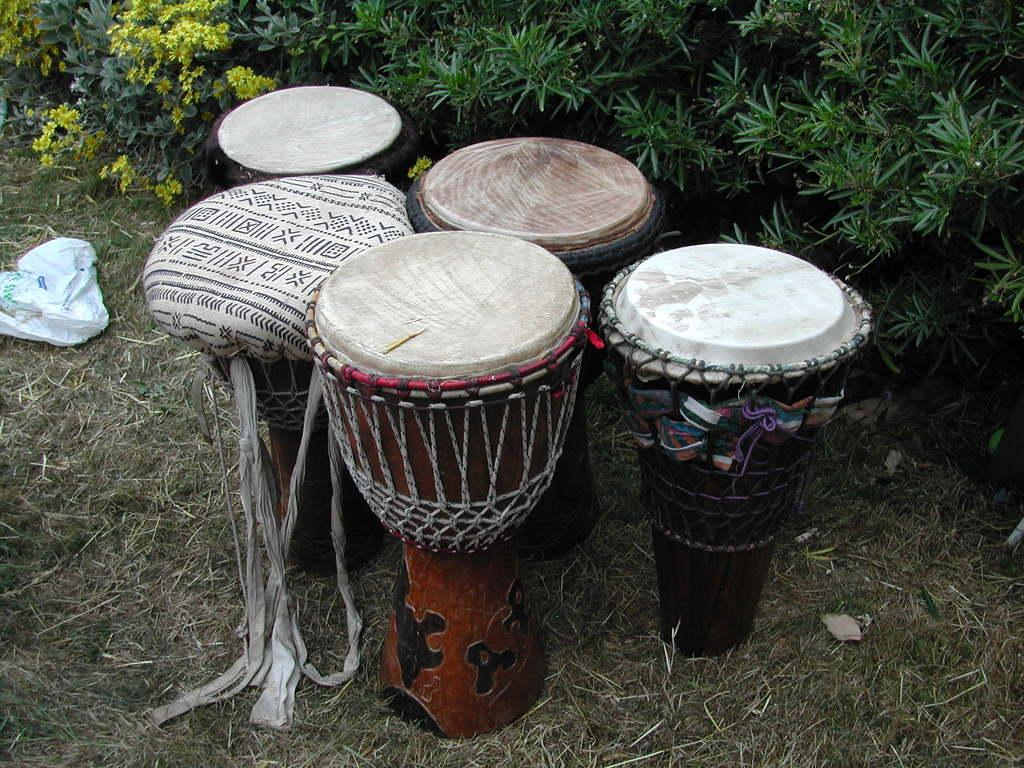What type of musical instruments are in the image? There are goblet-shaped hand drums in the image. What type of vegetation is visible at the bottom of the image? Grass is visible at the bottom of the image. What can be seen in the background of the image? There are plants and flowers in the background of the image. What is located on the left side of the image? There is a cover on the left side of the image. What type of debt is being discussed in the image? There is no mention of debt in the image; it features goblet-shaped hand drums, grass, plants, flowers, and a cover. What hobbies are the people in the image engaged in? The image does not show any people, so it is impossible to determine their hobbies. 